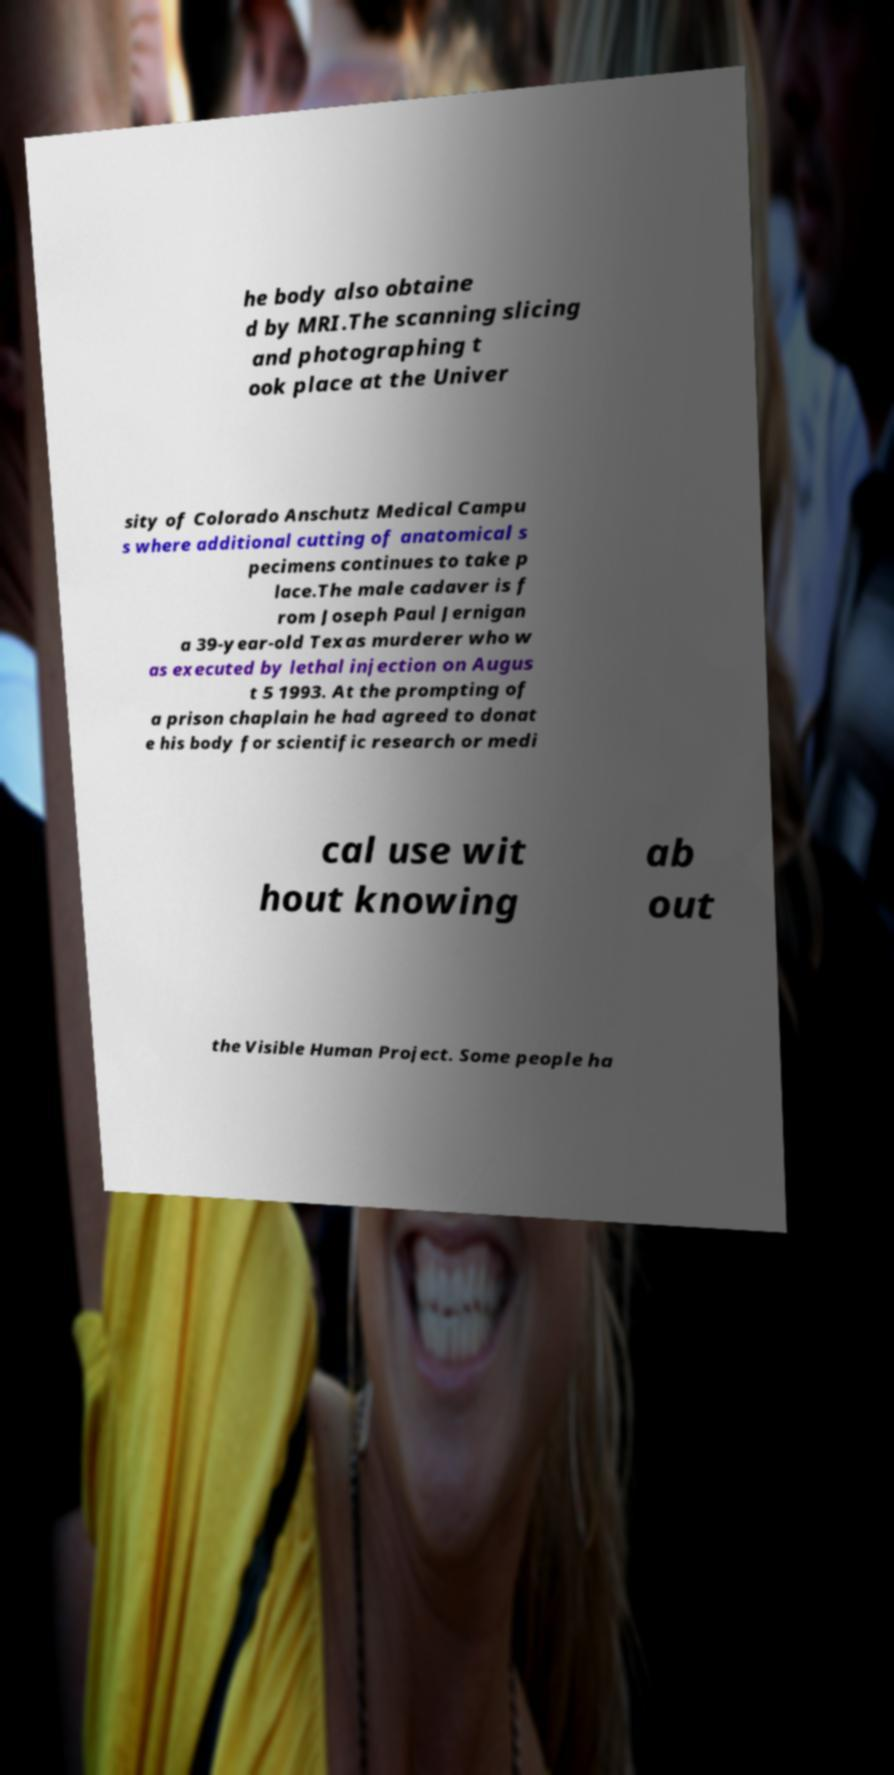Can you read and provide the text displayed in the image?This photo seems to have some interesting text. Can you extract and type it out for me? he body also obtaine d by MRI.The scanning slicing and photographing t ook place at the Univer sity of Colorado Anschutz Medical Campu s where additional cutting of anatomical s pecimens continues to take p lace.The male cadaver is f rom Joseph Paul Jernigan a 39-year-old Texas murderer who w as executed by lethal injection on Augus t 5 1993. At the prompting of a prison chaplain he had agreed to donat e his body for scientific research or medi cal use wit hout knowing ab out the Visible Human Project. Some people ha 